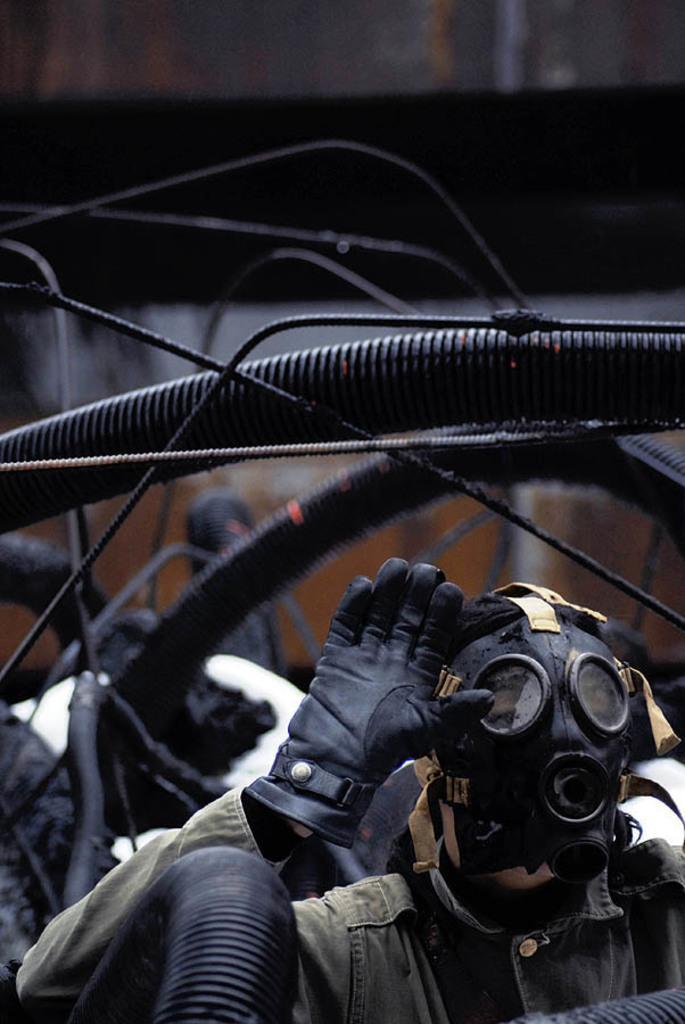Please provide a concise description of this image. In this picture we can see a person, and the person wore mask and glove, and also we can see few metal rods. 